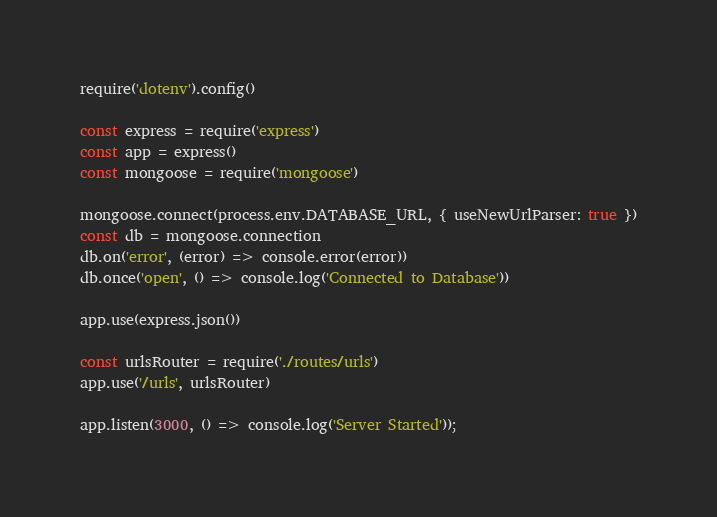Convert code to text. <code><loc_0><loc_0><loc_500><loc_500><_JavaScript_>require('dotenv').config()

const express = require('express')
const app = express()
const mongoose = require('mongoose')

mongoose.connect(process.env.DATABASE_URL, { useNewUrlParser: true })
const db = mongoose.connection
db.on('error', (error) => console.error(error))
db.once('open', () => console.log('Connected to Database'))

app.use(express.json())

const urlsRouter = require('./routes/urls')
app.use('/urls', urlsRouter)

app.listen(3000, () => console.log('Server Started'));

</code> 